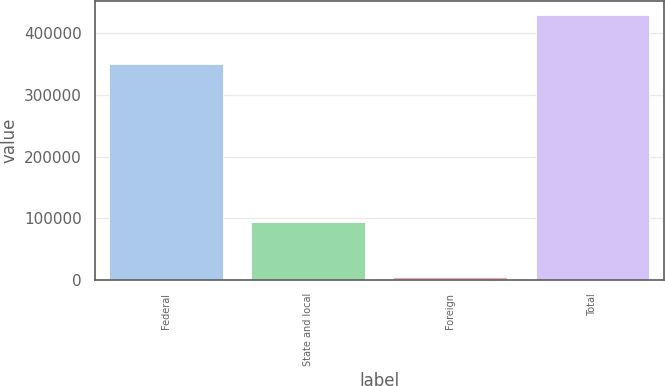<chart> <loc_0><loc_0><loc_500><loc_500><bar_chart><fcel>Federal<fcel>State and local<fcel>Foreign<fcel>Total<nl><fcel>349755<fcel>93229<fcel>4283<fcel>430127<nl></chart> 